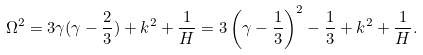Convert formula to latex. <formula><loc_0><loc_0><loc_500><loc_500>\Omega ^ { 2 } = 3 \gamma ( \gamma - \frac { 2 } { 3 } ) + k ^ { 2 } + \frac { 1 } { H } = 3 \left ( \gamma - \frac { 1 } { 3 } \right ) ^ { 2 } - \frac { 1 } { 3 } + k ^ { 2 } + \frac { 1 } { H } .</formula> 